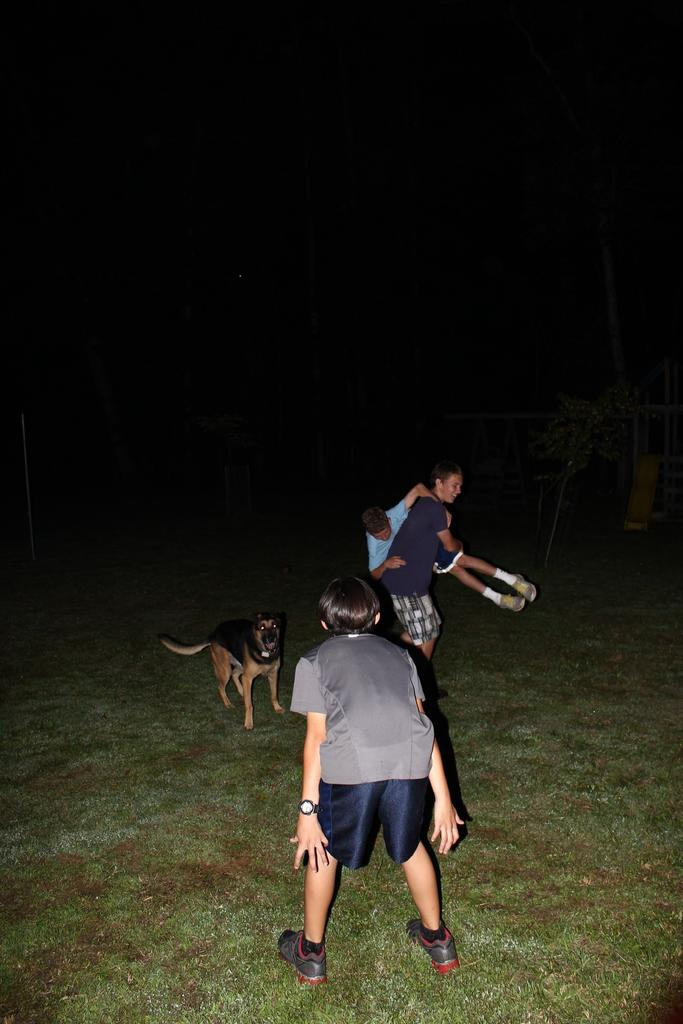What is the main subject of the image? The main subject of the image is a person standing on a greenery ground. What is in front of the person? There is a dog in front of the person. Are there any other people in the image? Yes, there is another person standing beside the dog. What is the second person doing? The second person is holding the first person. What type of route can be seen in the image? There is no route visible in the image; it features a person, a dog, and another person on a greenery ground. Can you tell me how many cows are present in the image? There are no cows present in the image. 